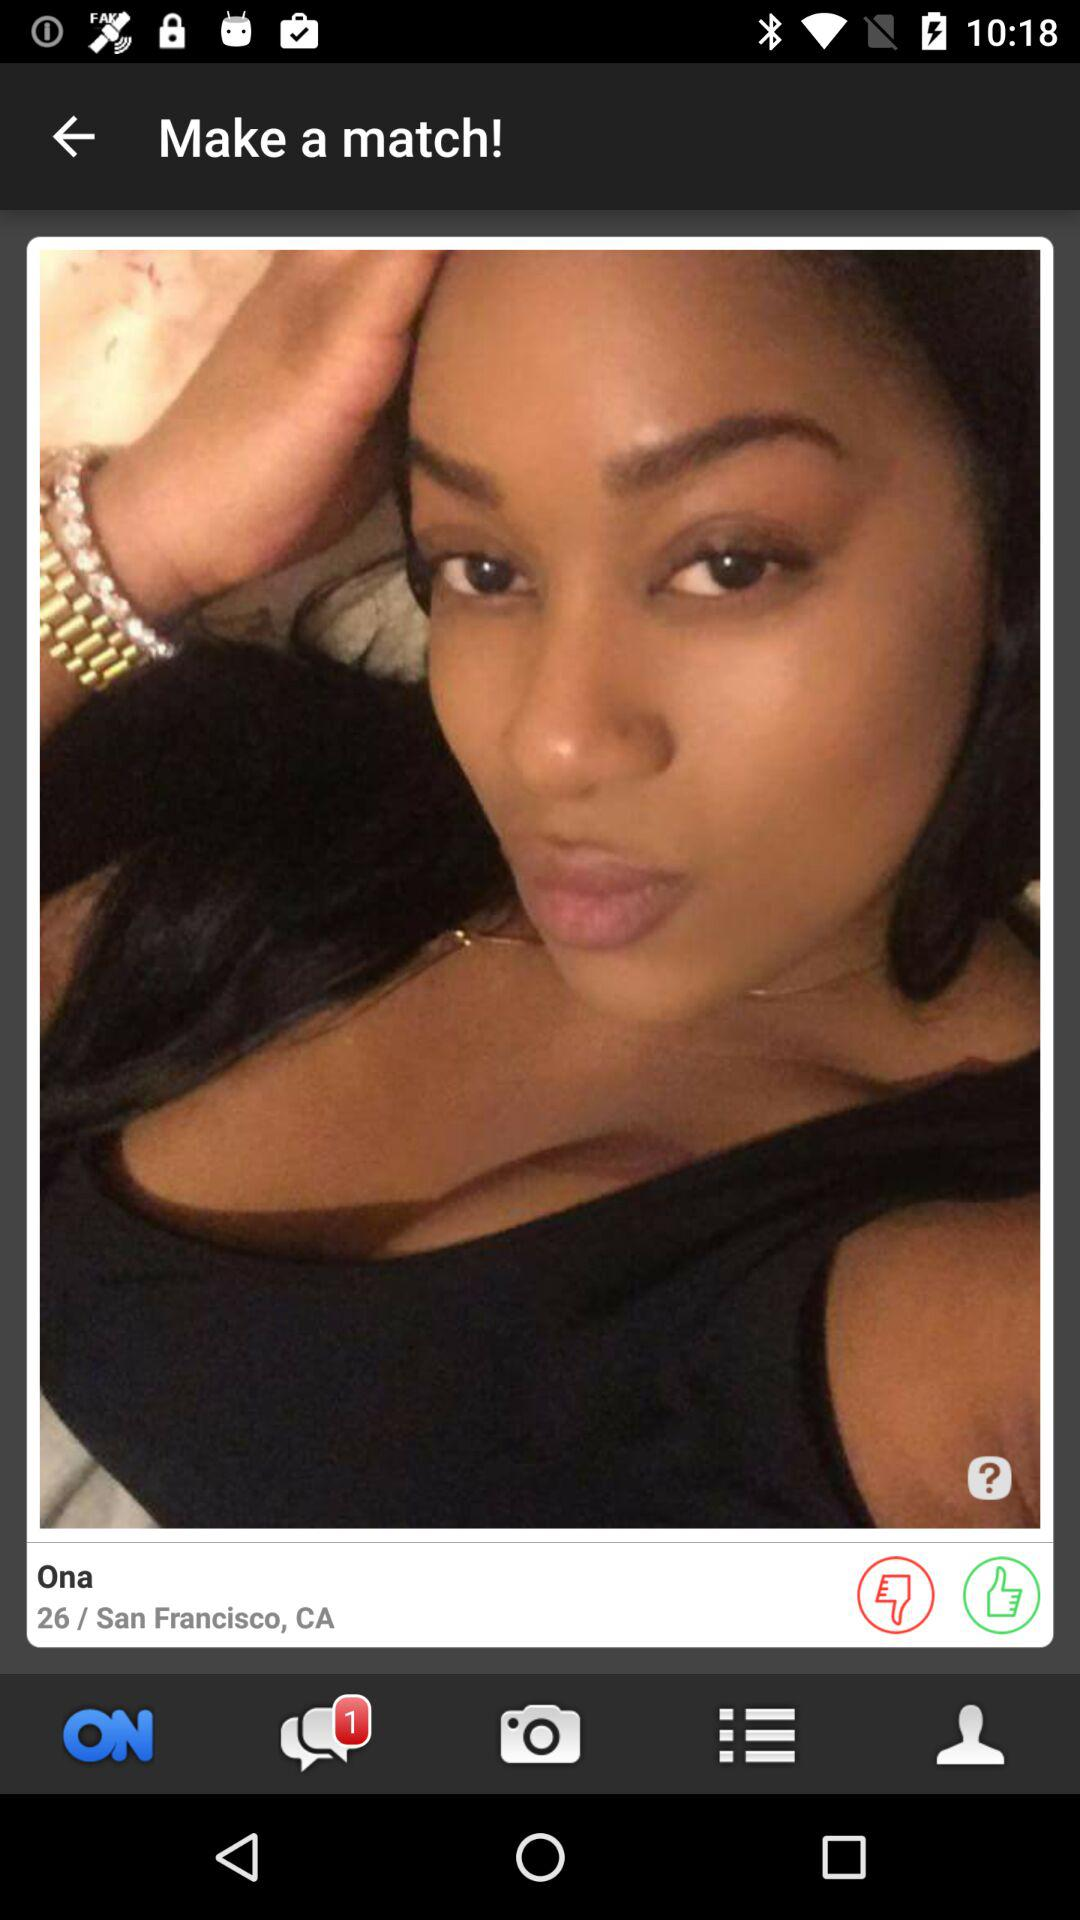What's the user name? The user name is Ona. 